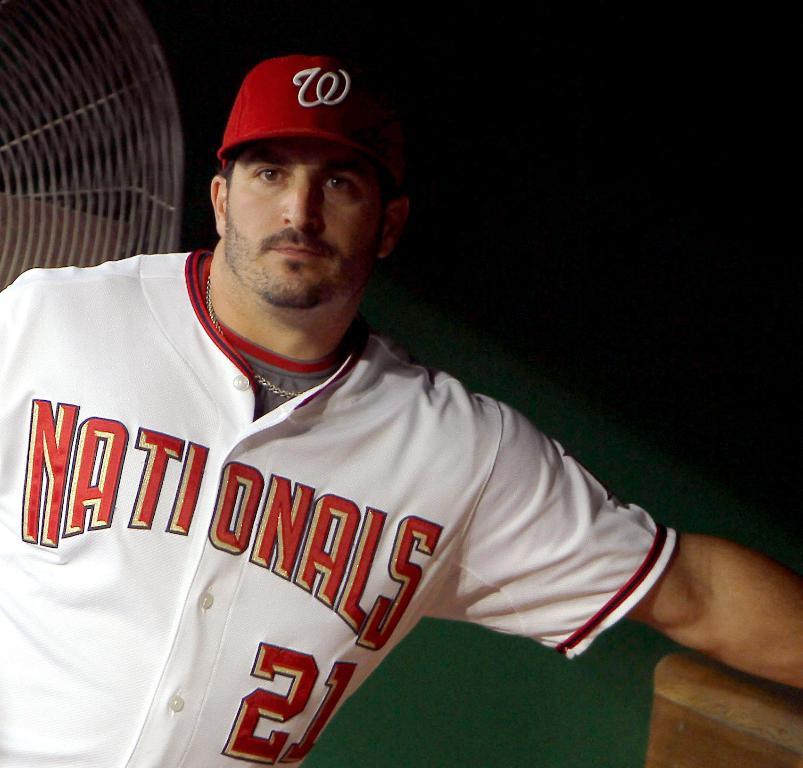What team does this baseball player play for?
Make the answer very short. Nationals. 